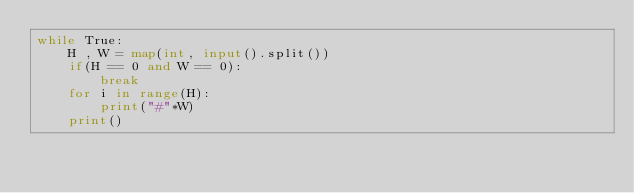<code> <loc_0><loc_0><loc_500><loc_500><_Python_>while True:
    H , W = map(int, input().split())
    if(H == 0 and W == 0):
        break
    for i in range(H):
        print("#"*W)
    print()
</code> 